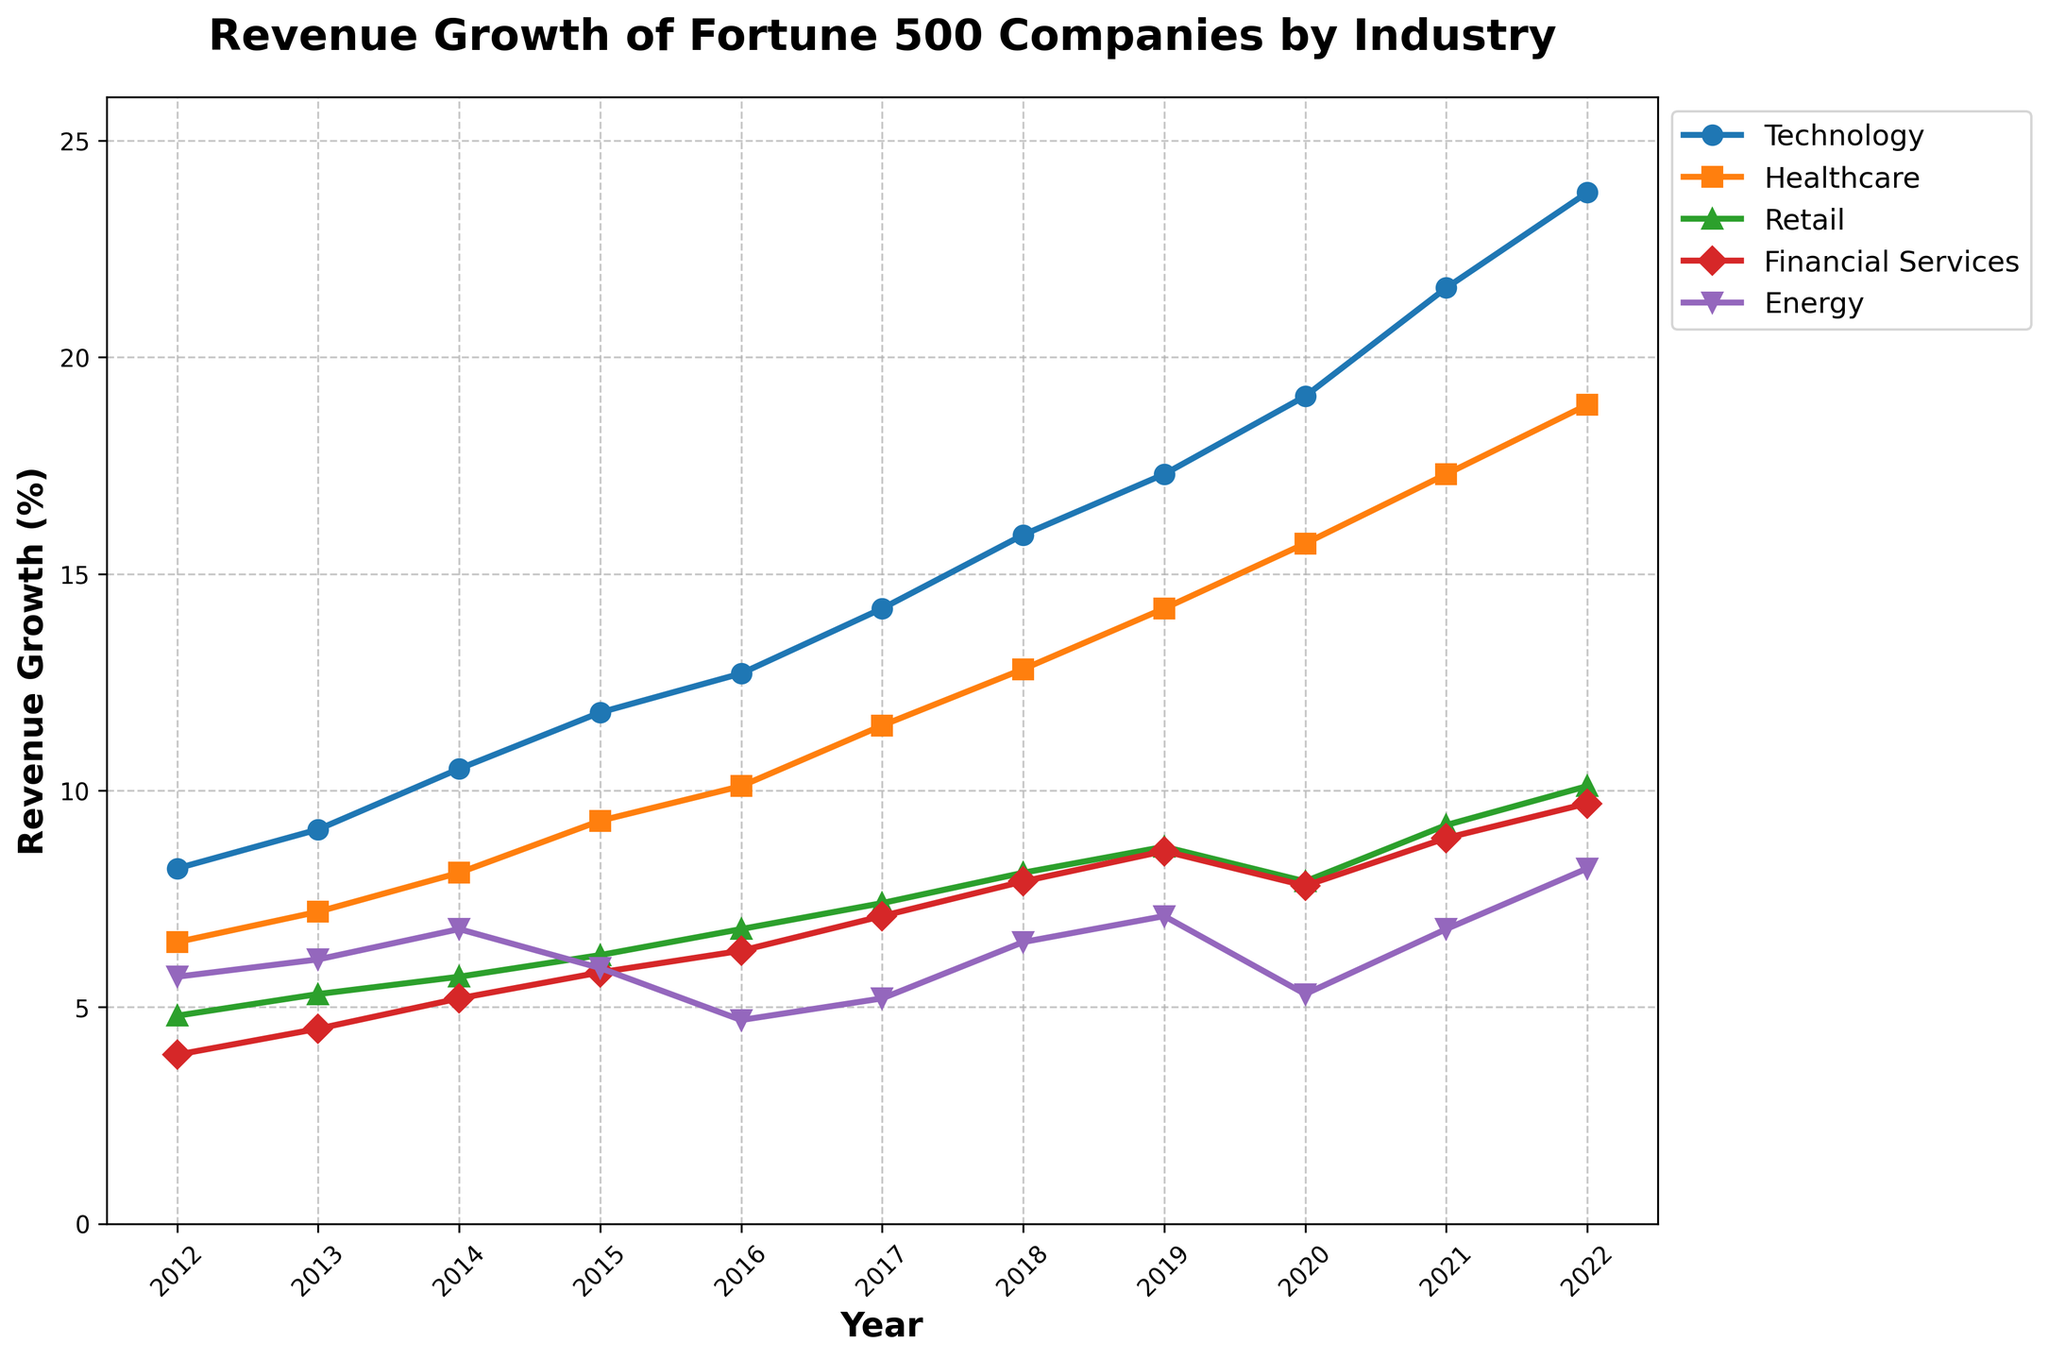What is the overall trend in revenue growth for the Technology sector over the past decade? The line for the Technology sector continually increases from 2012 (8.2%) to 2022 (23.8%), indicating a steady upward trend in revenue growth
Answer: Steady upward trend Which industry sector experienced the lowest revenue growth rate in 2020? By comparing the data points for 2020, Retail has the lowest revenue growth rate at 7.9%
Answer: Retail What was the revenue growth difference between Financial Services and Energy sectors in 2017? Financial Services had a revenue growth of 7.1%, and Energy had 5.2%. The difference is 7.1% - 5.2%
Answer: 1.9% Which sector showed the highest revenue growth rate in 2022? By observing the endpoints of the lines in 2022, Technology shows the highest revenue growth rate at 23.8%
Answer: Technology During which year did the Healthcare sector experience its highest annual revenue growth rate, and what was the value? The peak for the Healthcare line is at 2022, where the revenue growth rate is 18.9%
Answer: 2022, 18.9% How did the revenue growth for the Retail sector in 2015 compare to its revenue growth in 2019? In 2015, Retail's revenue growth was 6.2%, and in 2019, it was 8.7%. The difference is 8.7% - 6.2%
Answer: 2.5% Which two sectors had the most similar revenue growth rates in 2018? Comparing the 2018 data, Financial Services and Energy have the closest revenue growth rates at 7.9% and 6.5%, respectively, with a difference of 1.4%
Answer: Financial Services and Energy 